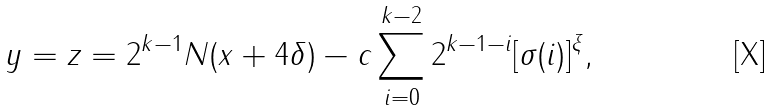<formula> <loc_0><loc_0><loc_500><loc_500>y = z = 2 ^ { k - 1 } N ( x + 4 \delta ) - c \sum _ { i = 0 } ^ { k - 2 } 2 ^ { k - 1 - i } [ \sigma ( i ) ] ^ { \xi } ,</formula> 